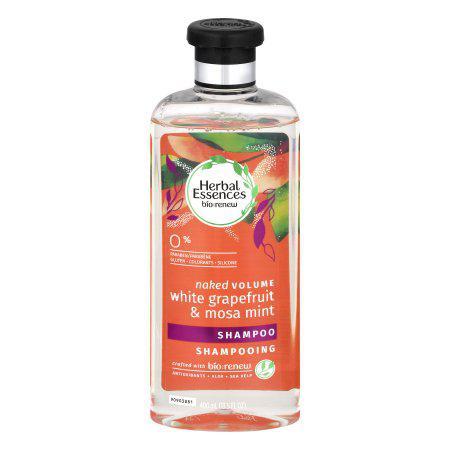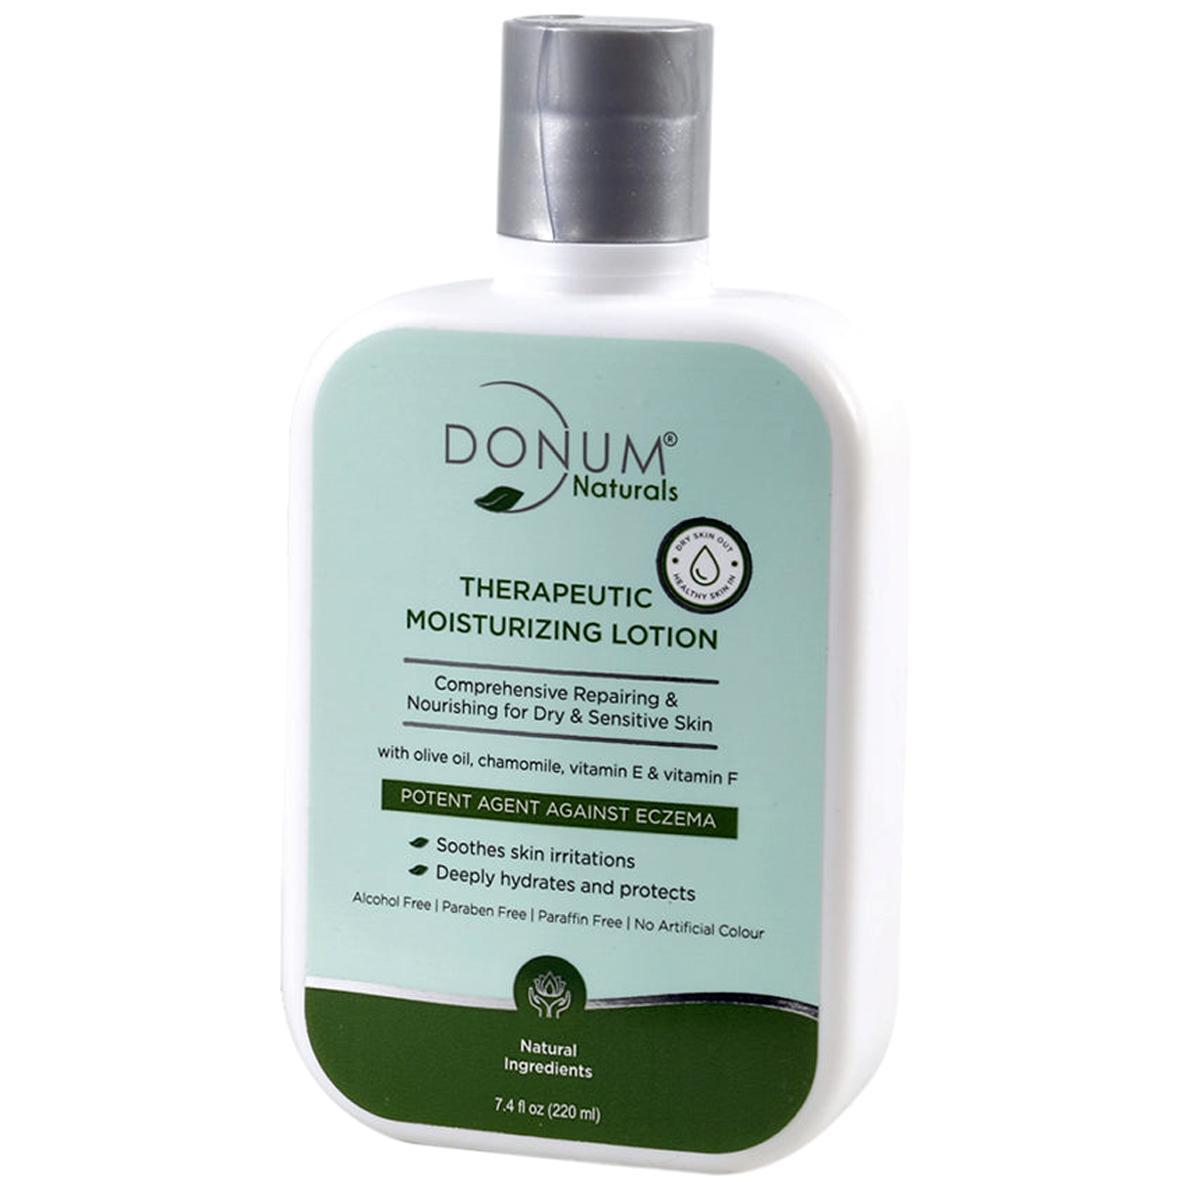The first image is the image on the left, the second image is the image on the right. For the images shown, is this caption "There are more items in the right image than in the left image." true? Answer yes or no. No. The first image is the image on the left, the second image is the image on the right. Given the left and right images, does the statement "One image includes an upright bottle with a black pump-top near a tube displayed upright sitting on its white cap." hold true? Answer yes or no. No. 